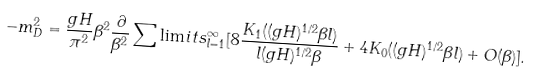<formula> <loc_0><loc_0><loc_500><loc_500>- m ^ { 2 } _ { D } = \frac { g H } { \pi ^ { 2 } } \beta ^ { 2 } \frac { \partial } { \beta ^ { 2 } } \sum \lim i t s _ { l = 1 } ^ { \infty } [ 8 \frac { K _ { 1 } ( ( g H ) ^ { 1 / 2 } \beta l ) } { l ( g H ) ^ { 1 / 2 } \beta } + 4 K _ { 0 } ( ( g H ) ^ { 1 / 2 } \beta l ) + O ( \beta ) ] .</formula> 